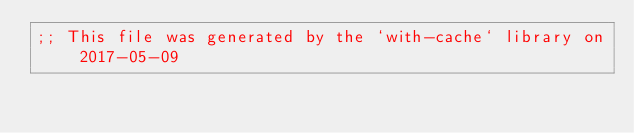Convert code to text. <code><loc_0><loc_0><loc_500><loc_500><_Racket_>;; This file was generated by the `with-cache` library on 2017-05-09</code> 